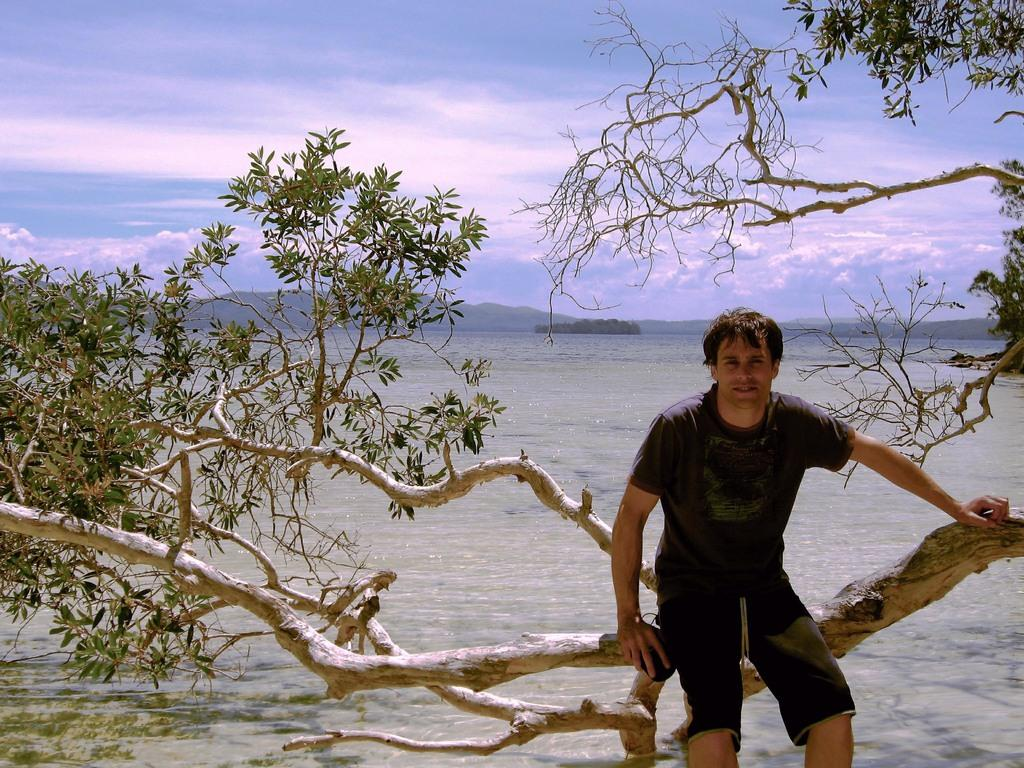What is the person in the image doing? The person is sitting on a tree in the image. What is the color of the tree? The tree is green. What can be seen in the background of the image? There is water and mountains visible in the background of the image. What is the color of the sky in the image? The sky is blue and white in the image. What type of noise can be heard coming from the flower in the image? There is no flower present in the image, so it is not possible to determine what noise might be coming from it. 